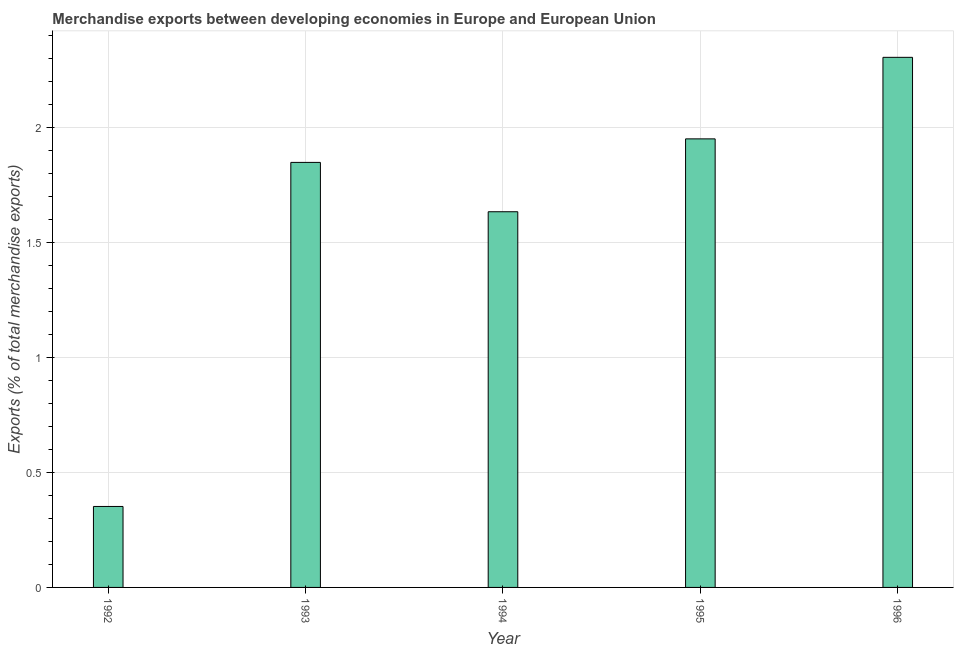What is the title of the graph?
Your response must be concise. Merchandise exports between developing economies in Europe and European Union. What is the label or title of the X-axis?
Your response must be concise. Year. What is the label or title of the Y-axis?
Your response must be concise. Exports (% of total merchandise exports). What is the merchandise exports in 1992?
Your answer should be very brief. 0.35. Across all years, what is the maximum merchandise exports?
Your answer should be very brief. 2.3. Across all years, what is the minimum merchandise exports?
Keep it short and to the point. 0.35. What is the sum of the merchandise exports?
Keep it short and to the point. 8.08. What is the difference between the merchandise exports in 1994 and 1996?
Keep it short and to the point. -0.67. What is the average merchandise exports per year?
Your answer should be very brief. 1.62. What is the median merchandise exports?
Offer a terse response. 1.85. In how many years, is the merchandise exports greater than 1.9 %?
Your answer should be very brief. 2. What is the ratio of the merchandise exports in 1992 to that in 1996?
Offer a very short reply. 0.15. What is the difference between the highest and the second highest merchandise exports?
Offer a very short reply. 0.35. Is the sum of the merchandise exports in 1992 and 1995 greater than the maximum merchandise exports across all years?
Provide a short and direct response. No. What is the difference between the highest and the lowest merchandise exports?
Offer a very short reply. 1.95. In how many years, is the merchandise exports greater than the average merchandise exports taken over all years?
Give a very brief answer. 4. How many years are there in the graph?
Offer a terse response. 5. Are the values on the major ticks of Y-axis written in scientific E-notation?
Keep it short and to the point. No. What is the Exports (% of total merchandise exports) of 1992?
Give a very brief answer. 0.35. What is the Exports (% of total merchandise exports) in 1993?
Provide a succinct answer. 1.85. What is the Exports (% of total merchandise exports) in 1994?
Your answer should be very brief. 1.63. What is the Exports (% of total merchandise exports) of 1995?
Keep it short and to the point. 1.95. What is the Exports (% of total merchandise exports) in 1996?
Provide a succinct answer. 2.3. What is the difference between the Exports (% of total merchandise exports) in 1992 and 1993?
Ensure brevity in your answer.  -1.49. What is the difference between the Exports (% of total merchandise exports) in 1992 and 1994?
Make the answer very short. -1.28. What is the difference between the Exports (% of total merchandise exports) in 1992 and 1995?
Offer a terse response. -1.6. What is the difference between the Exports (% of total merchandise exports) in 1992 and 1996?
Your answer should be compact. -1.95. What is the difference between the Exports (% of total merchandise exports) in 1993 and 1994?
Keep it short and to the point. 0.21. What is the difference between the Exports (% of total merchandise exports) in 1993 and 1995?
Provide a succinct answer. -0.1. What is the difference between the Exports (% of total merchandise exports) in 1993 and 1996?
Your answer should be compact. -0.46. What is the difference between the Exports (% of total merchandise exports) in 1994 and 1995?
Keep it short and to the point. -0.32. What is the difference between the Exports (% of total merchandise exports) in 1994 and 1996?
Your answer should be very brief. -0.67. What is the difference between the Exports (% of total merchandise exports) in 1995 and 1996?
Provide a succinct answer. -0.35. What is the ratio of the Exports (% of total merchandise exports) in 1992 to that in 1993?
Offer a terse response. 0.19. What is the ratio of the Exports (% of total merchandise exports) in 1992 to that in 1994?
Give a very brief answer. 0.22. What is the ratio of the Exports (% of total merchandise exports) in 1992 to that in 1995?
Offer a terse response. 0.18. What is the ratio of the Exports (% of total merchandise exports) in 1992 to that in 1996?
Your answer should be very brief. 0.15. What is the ratio of the Exports (% of total merchandise exports) in 1993 to that in 1994?
Keep it short and to the point. 1.13. What is the ratio of the Exports (% of total merchandise exports) in 1993 to that in 1995?
Provide a short and direct response. 0.95. What is the ratio of the Exports (% of total merchandise exports) in 1993 to that in 1996?
Keep it short and to the point. 0.8. What is the ratio of the Exports (% of total merchandise exports) in 1994 to that in 1995?
Your answer should be very brief. 0.84. What is the ratio of the Exports (% of total merchandise exports) in 1994 to that in 1996?
Offer a very short reply. 0.71. What is the ratio of the Exports (% of total merchandise exports) in 1995 to that in 1996?
Offer a terse response. 0.85. 